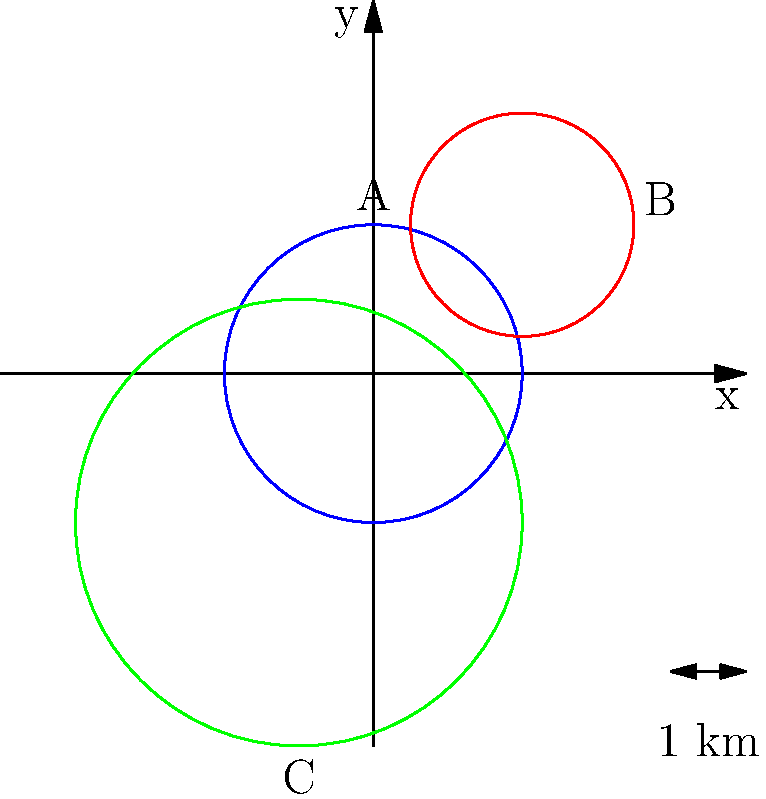In a study of owl home ranges, three different species (A, B, and C) were observed. Their territories are represented as circular areas in the polar coordinate system, where each unit represents 1 km. Given that species A has a home range centered at $(0,0)$ with a radius of 2 km, species B is centered at $(2,2)$ with a radius of 1.5 km, and species C is centered at $(-1,-2)$ with a radius of 3 km, calculate the total area covered by all three species' home ranges. Round your answer to the nearest whole number. To solve this problem, we need to follow these steps:

1. Calculate the area of each circular home range using the formula $A = \pi r^2$, where $r$ is the radius.

2. For species A:
   $A_A = \pi (2)^2 = 4\pi \approx 12.57$ km²

3. For species B:
   $A_B = \pi (1.5)^2 = 2.25\pi \approx 7.07$ km²

4. For species C:
   $A_C = \pi (3)^2 = 9\pi \approx 28.27$ km²

5. Sum up the individual areas:
   $A_{total} = A_A + A_B + A_C = 12.57 + 7.07 + 28.27 = 47.91$ km²

6. Round to the nearest whole number:
   $47.91 \approx 48$ km²

Therefore, the total area covered by all three species' home ranges is approximately 48 km².
Answer: 48 km² 